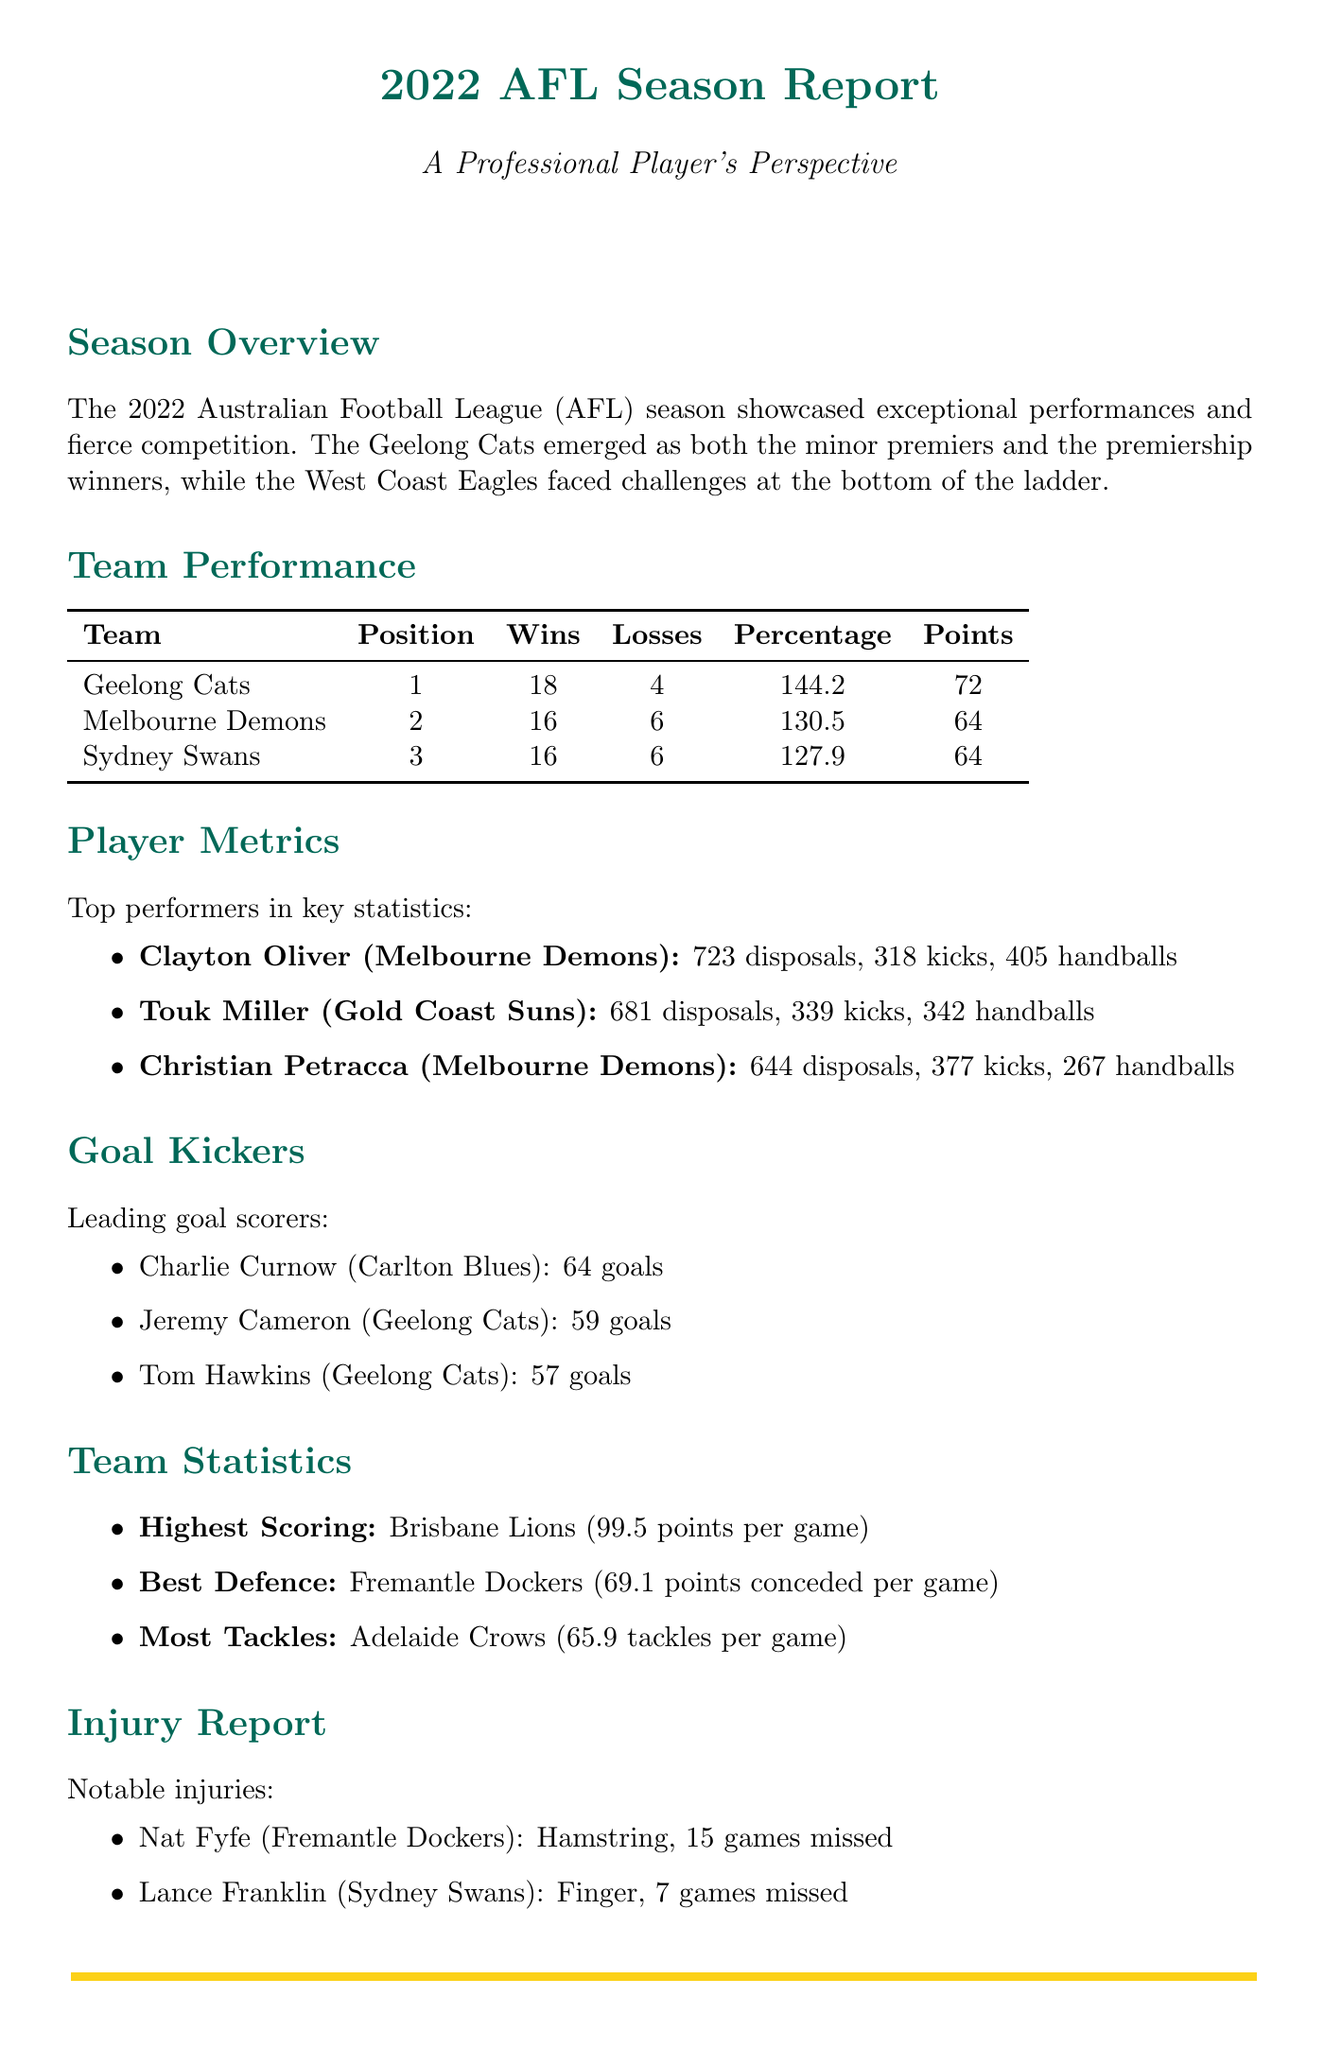What team won the premiership? The document states that the Geelong Cats emerged as the premiership winners.
Answer: Geelong Cats How many games did the West Coast Eagles win? The document lists the West Coast Eagles as the team that faced challenges at the bottom of the ladder, specifically as the wooden spoon recipient, which indicates they won no more than a few games.
Answer: 4 Who had the most disposals in the season? The player metrics indicate that Clayton Oliver had the highest disposals with 723.
Answer: Clayton Oliver Which team had the best defense? The document specifies that the Fremantle Dockers had the best defense with an average of 69.1 points conceded per game.
Answer: Fremantle Dockers What was the average score of the highest-scoring team? The document mentions that the Brisbane Lions had an average score of 99.5 points per game.
Answer: 99.5 How many goals did Charlie Curnow score? The goal kickers section lists Charlie Curnow as scoring 64 goals.
Answer: 64 Who replaced David Noble as the coach of North Melbourne Kangaroos? The document details that Alastair Clarkson replaced David Noble as coach.
Answer: Alastair Clarkson Which player missed 15 games due to injury? The injury report states that Nat Fyfe missed 15 games due to a hamstring injury.
Answer: Nat Fyfe What is the position of Christian Petracca in the player metrics? The player metrics do not specify positions, but player metrics detail Christian Petracca's statistics.
Answer: Melbourne Demons 